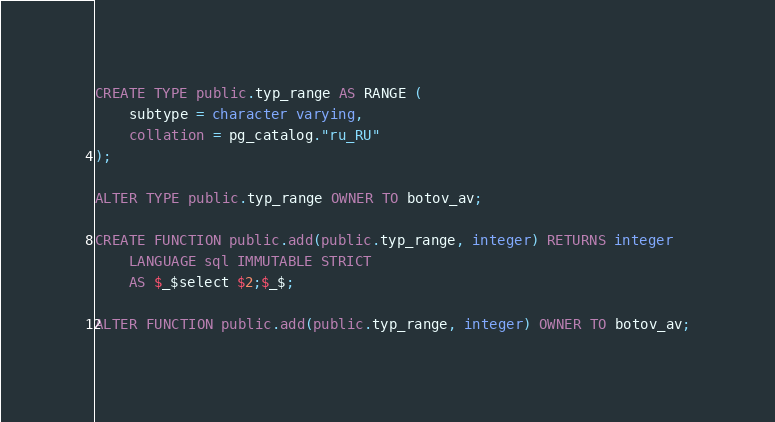Convert code to text. <code><loc_0><loc_0><loc_500><loc_500><_SQL_>CREATE TYPE public.typ_range AS RANGE (
    subtype = character varying,
    collation = pg_catalog."ru_RU"
);

ALTER TYPE public.typ_range OWNER TO botov_av;

CREATE FUNCTION public.add(public.typ_range, integer) RETURNS integer
    LANGUAGE sql IMMUTABLE STRICT
    AS $_$select $2;$_$;

ALTER FUNCTION public.add(public.typ_range, integer) OWNER TO botov_av;</code> 